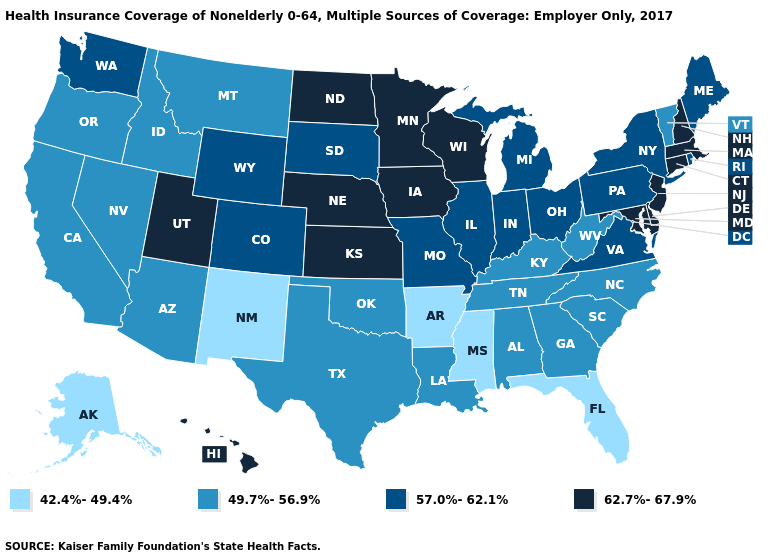What is the value of Nevada?
Concise answer only. 49.7%-56.9%. What is the value of Arkansas?
Write a very short answer. 42.4%-49.4%. Among the states that border Mississippi , which have the lowest value?
Be succinct. Arkansas. Among the states that border Connecticut , which have the highest value?
Short answer required. Massachusetts. Name the states that have a value in the range 49.7%-56.9%?
Answer briefly. Alabama, Arizona, California, Georgia, Idaho, Kentucky, Louisiana, Montana, Nevada, North Carolina, Oklahoma, Oregon, South Carolina, Tennessee, Texas, Vermont, West Virginia. Is the legend a continuous bar?
Be succinct. No. Name the states that have a value in the range 42.4%-49.4%?
Keep it brief. Alaska, Arkansas, Florida, Mississippi, New Mexico. What is the lowest value in states that border Washington?
Be succinct. 49.7%-56.9%. Does Delaware have the highest value in the South?
Short answer required. Yes. What is the highest value in the USA?
Give a very brief answer. 62.7%-67.9%. Does New Jersey have a higher value than Louisiana?
Quick response, please. Yes. Name the states that have a value in the range 42.4%-49.4%?
Write a very short answer. Alaska, Arkansas, Florida, Mississippi, New Mexico. What is the highest value in the MidWest ?
Be succinct. 62.7%-67.9%. 